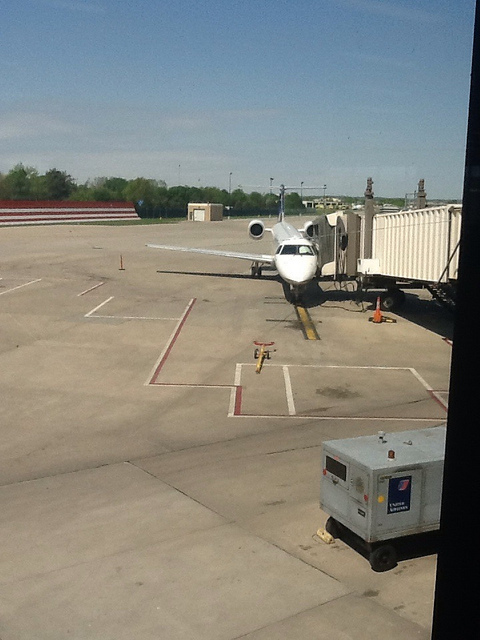<image>What is the large metal thing on the right? It's ambiguous what the large metal thing on the right is. It could be an airplane connector, truck, passenger chute, small office, trailer, box, luggage container, walkway, bridge, or something else. What is the large metal thing on the right? I am not sure what is the large metal thing on the right. It can be an airplane connector, truck, passenger chute, or something else. 